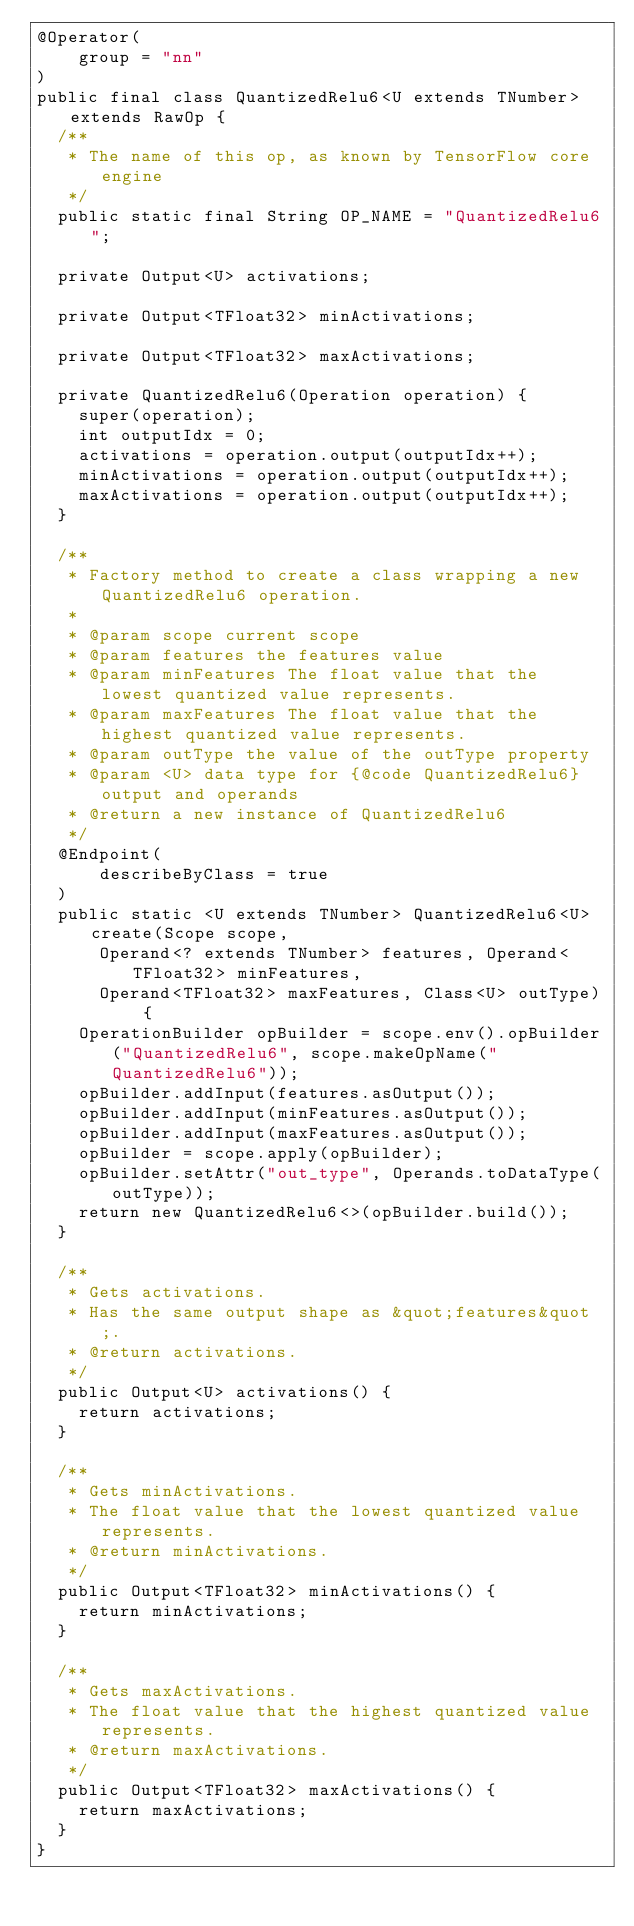<code> <loc_0><loc_0><loc_500><loc_500><_Java_>@Operator(
    group = "nn"
)
public final class QuantizedRelu6<U extends TNumber> extends RawOp {
  /**
   * The name of this op, as known by TensorFlow core engine
   */
  public static final String OP_NAME = "QuantizedRelu6";

  private Output<U> activations;

  private Output<TFloat32> minActivations;

  private Output<TFloat32> maxActivations;

  private QuantizedRelu6(Operation operation) {
    super(operation);
    int outputIdx = 0;
    activations = operation.output(outputIdx++);
    minActivations = operation.output(outputIdx++);
    maxActivations = operation.output(outputIdx++);
  }

  /**
   * Factory method to create a class wrapping a new QuantizedRelu6 operation.
   *
   * @param scope current scope
   * @param features the features value
   * @param minFeatures The float value that the lowest quantized value represents.
   * @param maxFeatures The float value that the highest quantized value represents.
   * @param outType the value of the outType property
   * @param <U> data type for {@code QuantizedRelu6} output and operands
   * @return a new instance of QuantizedRelu6
   */
  @Endpoint(
      describeByClass = true
  )
  public static <U extends TNumber> QuantizedRelu6<U> create(Scope scope,
      Operand<? extends TNumber> features, Operand<TFloat32> minFeatures,
      Operand<TFloat32> maxFeatures, Class<U> outType) {
    OperationBuilder opBuilder = scope.env().opBuilder("QuantizedRelu6", scope.makeOpName("QuantizedRelu6"));
    opBuilder.addInput(features.asOutput());
    opBuilder.addInput(minFeatures.asOutput());
    opBuilder.addInput(maxFeatures.asOutput());
    opBuilder = scope.apply(opBuilder);
    opBuilder.setAttr("out_type", Operands.toDataType(outType));
    return new QuantizedRelu6<>(opBuilder.build());
  }

  /**
   * Gets activations.
   * Has the same output shape as &quot;features&quot;.
   * @return activations.
   */
  public Output<U> activations() {
    return activations;
  }

  /**
   * Gets minActivations.
   * The float value that the lowest quantized value represents.
   * @return minActivations.
   */
  public Output<TFloat32> minActivations() {
    return minActivations;
  }

  /**
   * Gets maxActivations.
   * The float value that the highest quantized value represents.
   * @return maxActivations.
   */
  public Output<TFloat32> maxActivations() {
    return maxActivations;
  }
}
</code> 